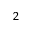Convert formula to latex. <formula><loc_0><loc_0><loc_500><loc_500>^ { 2 }</formula> 